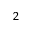Convert formula to latex. <formula><loc_0><loc_0><loc_500><loc_500>^ { 2 }</formula> 